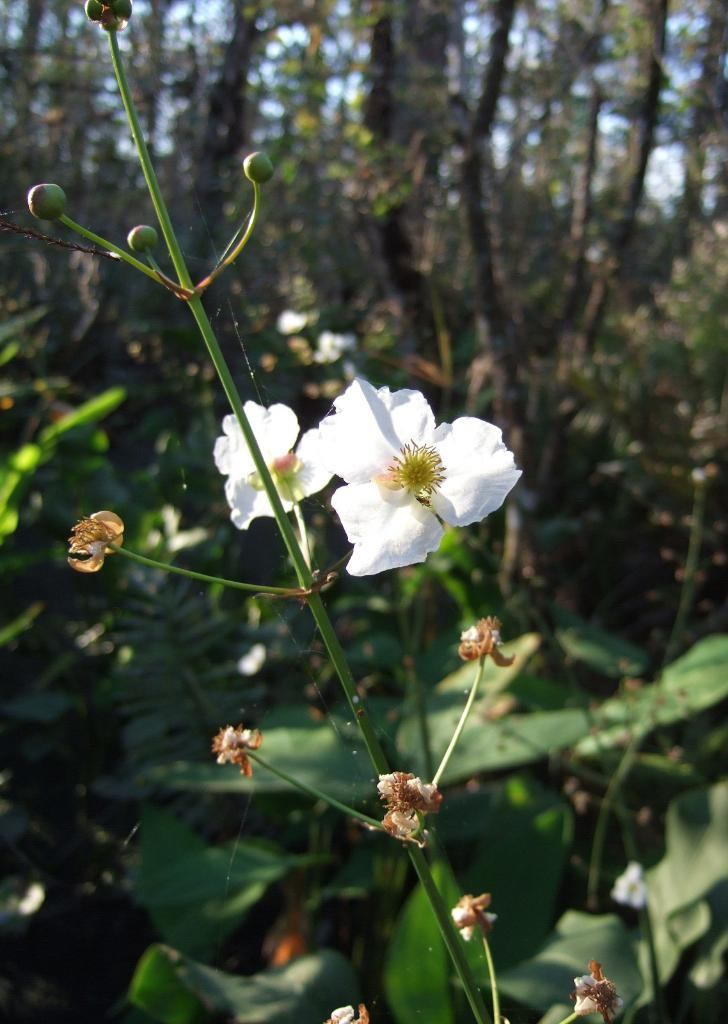What type of plant accessory is present in the image? There are flowers for a plant in the image. What can be seen in the distance in the image? There are trees in the background of the image. How is the background of the image depicted? The background is blurred in the image. What type of trail can be seen in the image? There is no trail present in the image; it features flowers for a plant and trees in the background. How does the sister interact with the flowers in the image? There is no sister present in the image, only flowers for a plant and trees in the background. 